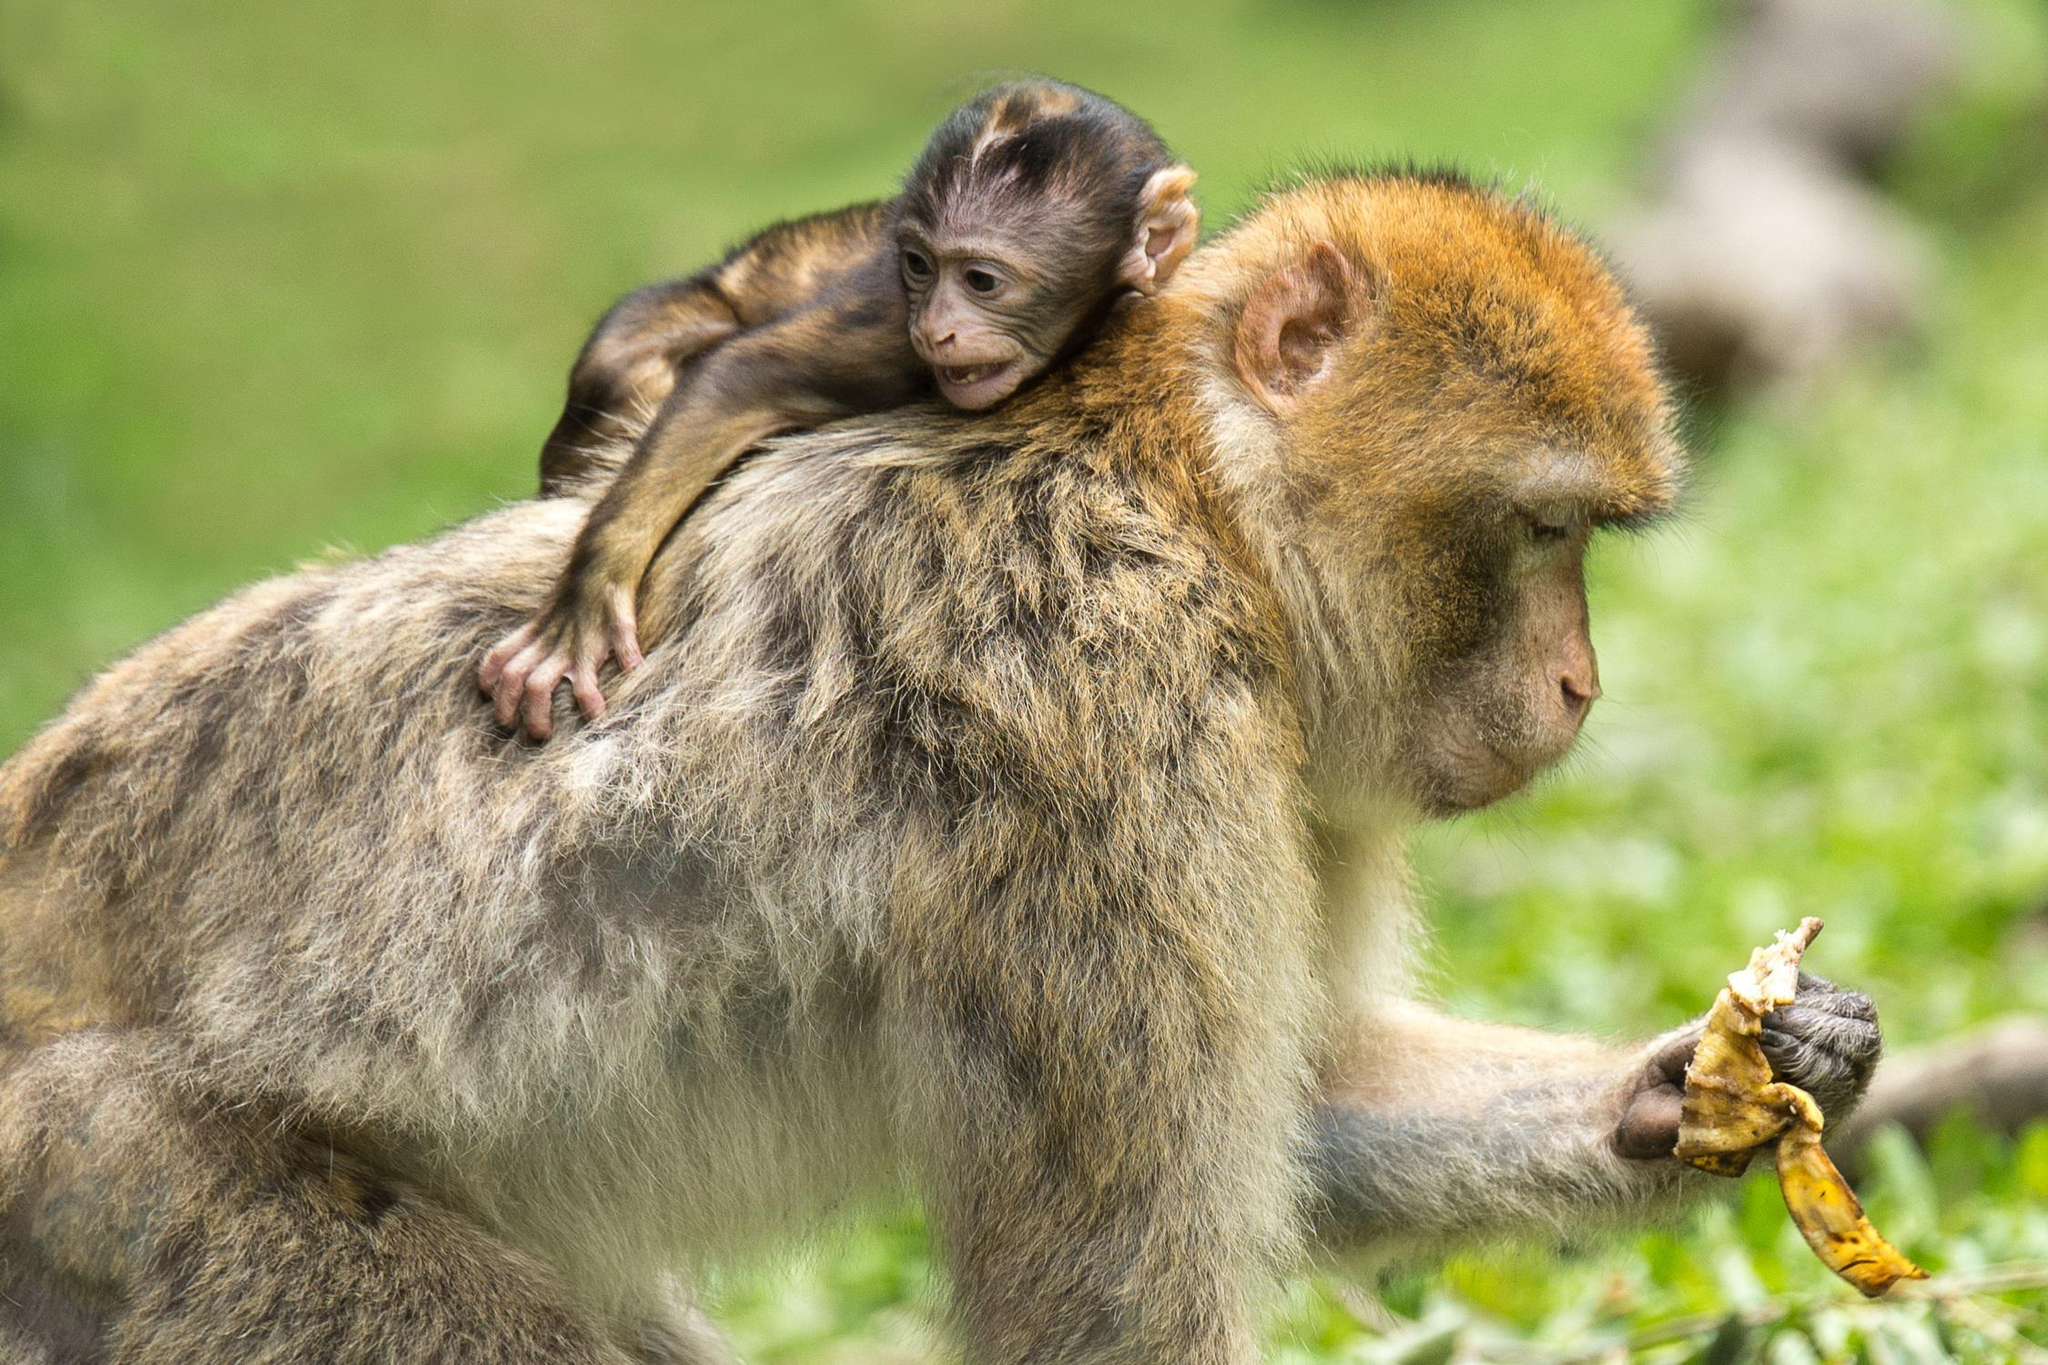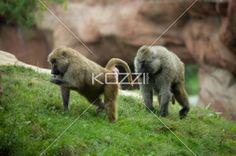The first image is the image on the left, the second image is the image on the right. Evaluate the accuracy of this statement regarding the images: "In the left image, if you count the animals, you will have an even number.". Is it true? Answer yes or no. Yes. The first image is the image on the left, the second image is the image on the right. Assess this claim about the two images: "in the right side the primate has something in its hands". Correct or not? Answer yes or no. No. 